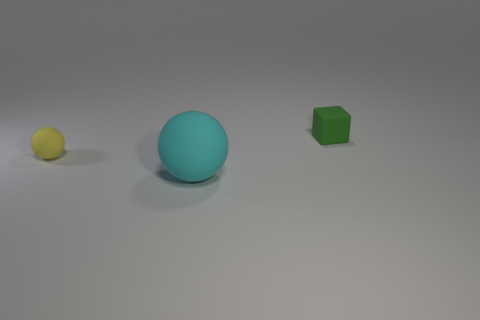Are there any other things that are the same size as the cyan rubber thing?
Ensure brevity in your answer.  No. How many small green matte objects are right of the tiny object in front of the small matte block?
Your answer should be very brief. 1. What number of other objects are the same shape as the green matte thing?
Give a very brief answer. 0. What number of things are either large purple matte balls or rubber spheres in front of the yellow sphere?
Offer a very short reply. 1. Are there more big things in front of the small sphere than green rubber cubes that are in front of the green object?
Keep it short and to the point. Yes. What shape is the small rubber object on the right side of the rubber sphere on the right side of the tiny object that is on the left side of the rubber cube?
Provide a succinct answer. Cube. What is the shape of the rubber object right of the ball in front of the tiny yellow rubber object?
Make the answer very short. Cube. Is there a cyan sphere that has the same material as the green block?
Offer a very short reply. Yes. What number of blue objects are either blocks or large matte cylinders?
Keep it short and to the point. 0. There is a yellow sphere that is the same material as the green cube; what size is it?
Your response must be concise. Small. 